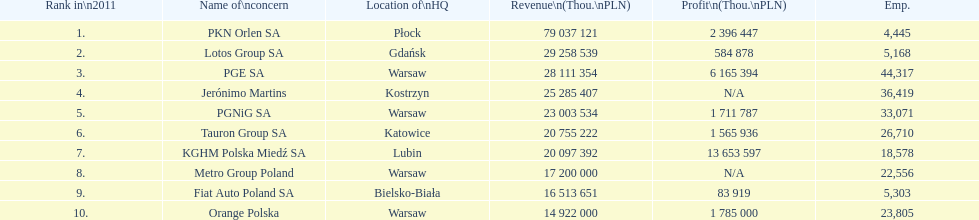What is the number of employees who work for pgnig sa? 33,071. 